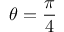Convert formula to latex. <formula><loc_0><loc_0><loc_500><loc_500>\theta = \frac { \pi } { 4 }</formula> 